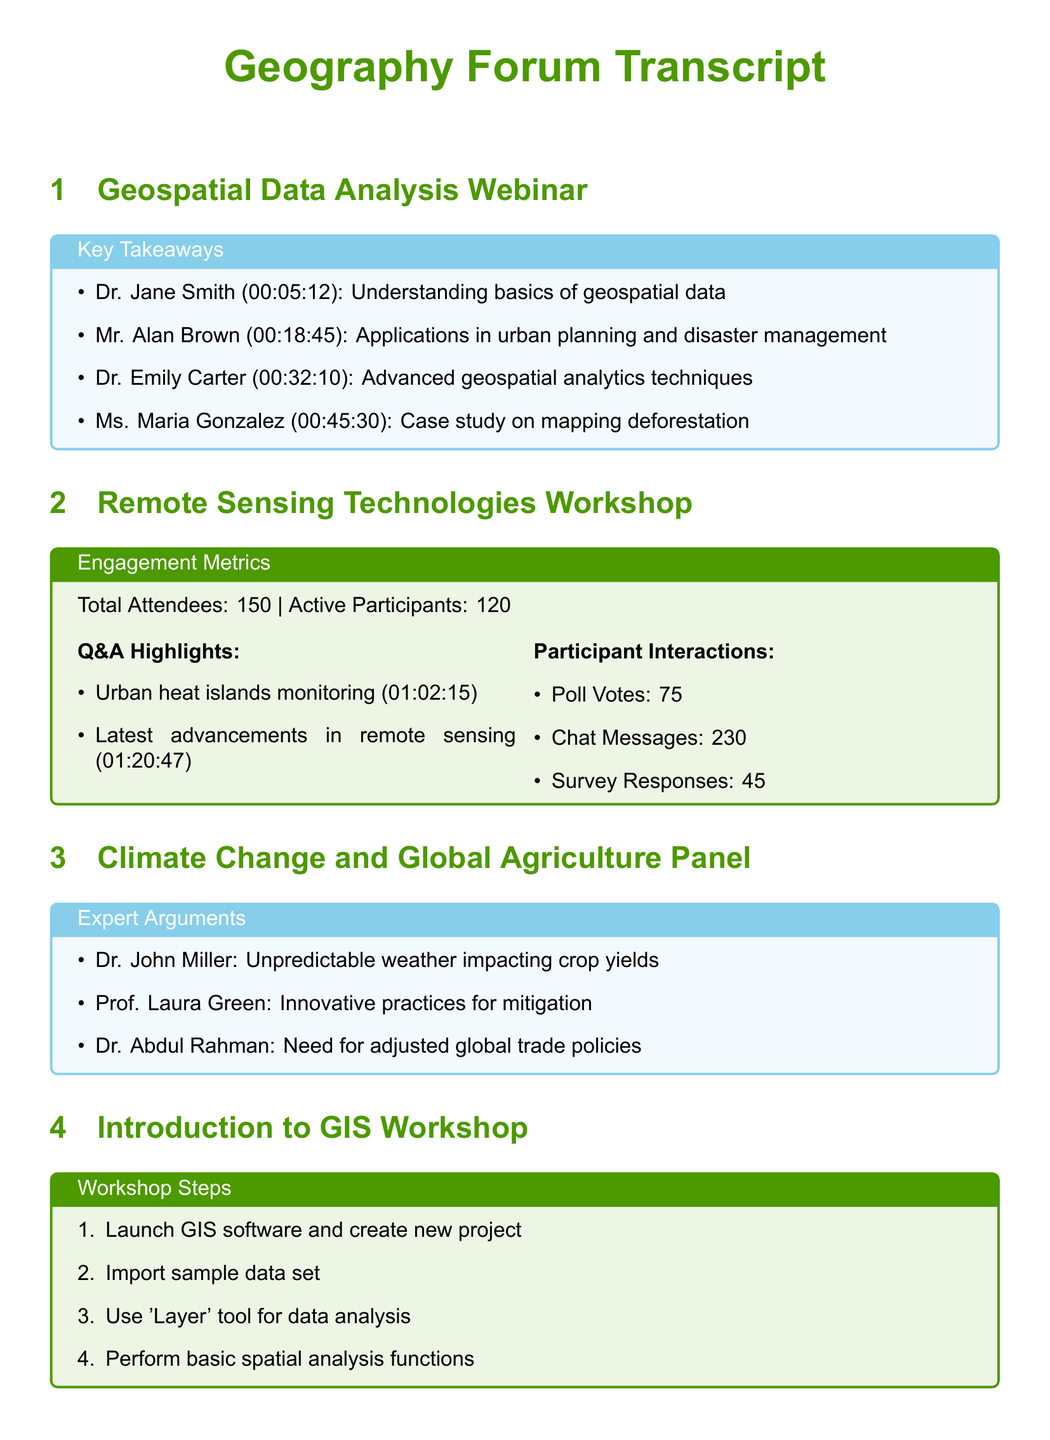What is the topic of the webinar? The main topic of the webinar is geospatial data analysis, as stated in the title.
Answer: geospatial data analysis Who presented on urban planning applications? Mr. Alan Brown discussed the applications of geospatial data in urban planning during the webinar.
Answer: Mr. Alan Brown What was the total number of attendees for the remote sensing workshop? The document states that the total number of attendees for the workshop was 150.
Answer: 150 How many active participants engaged in the remote sensing workshop? The document notes that there were 120 active participants in the workshop.
Answer: 120 Which method was highlighted for crop yield issues? Dr. John Miller highlighted unpredictable weather as impacting crop yields in the panel debate.
Answer: unpredictable weather What is the first step in the GIS workshop? The first step outlined in the workshop is to launch GIS software and create a new project.
Answer: Launch GIS software and create new project How many poll votes were recorded during the workshop? The document specifies that there were 75 poll votes recorded during the remote sensing workshop.
Answer: 75 Which collaboration opportunity involved GIS? The collaboration opportunity involving GIS was presented by Alice Johnson & Dr. Sarah Lee.
Answer: Alice Johnson & Dr. Sarah Lee What is one application mentioned for remote sensing? One application mentioned for remote sensing is monitoring urban heat islands.
Answer: monitoring urban heat islands 